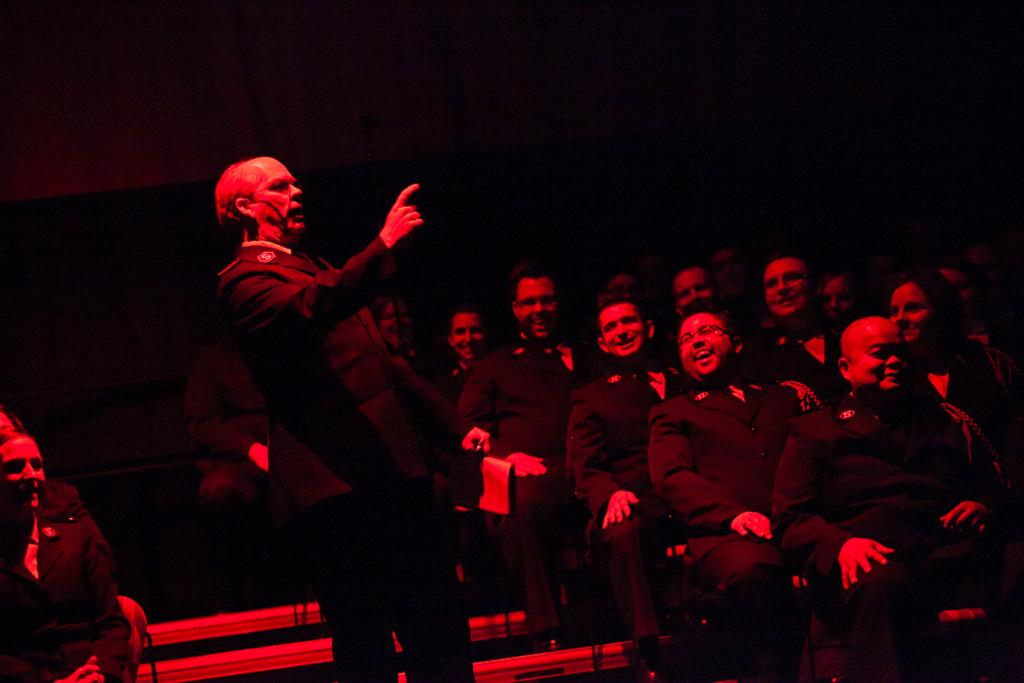What is the person in the image wearing? The person in the image is wearing a black suit. What is the person in the black suit doing? The person in the black suit is standing. Are there any other people in the image? Yes, there are other persons sitting in chairs on either side of the person in the black suit. What is the weather like at the seashore in the image? There is no seashore present in the image, so it is not possible to determine the weather conditions there. 